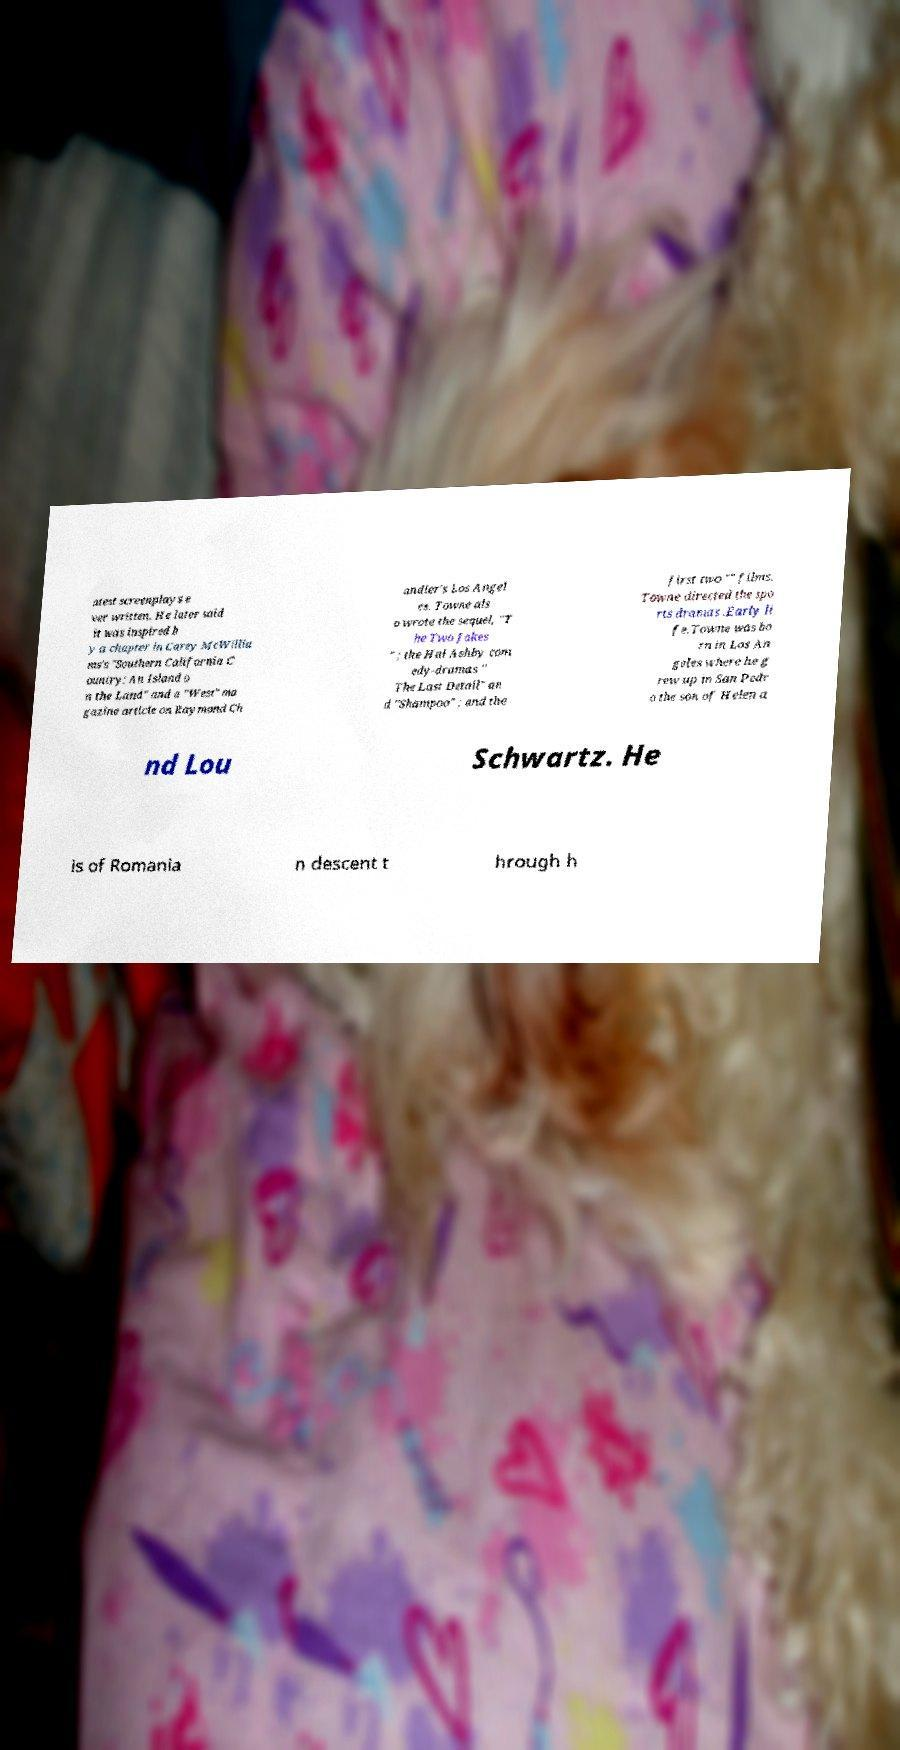Could you assist in decoding the text presented in this image and type it out clearly? atest screenplays e ver written. He later said it was inspired b y a chapter in Carey McWillia ms's "Southern California C ountry: An Island o n the Land" and a "West" ma gazine article on Raymond Ch andler's Los Angel es. Towne als o wrote the sequel, "T he Two Jakes " ; the Hal Ashby com edy-dramas " The Last Detail" an d "Shampoo" ; and the first two "" films. Towne directed the spo rts dramas .Early li fe.Towne was bo rn in Los An geles where he g rew up in San Pedr o the son of Helen a nd Lou Schwartz. He is of Romania n descent t hrough h 